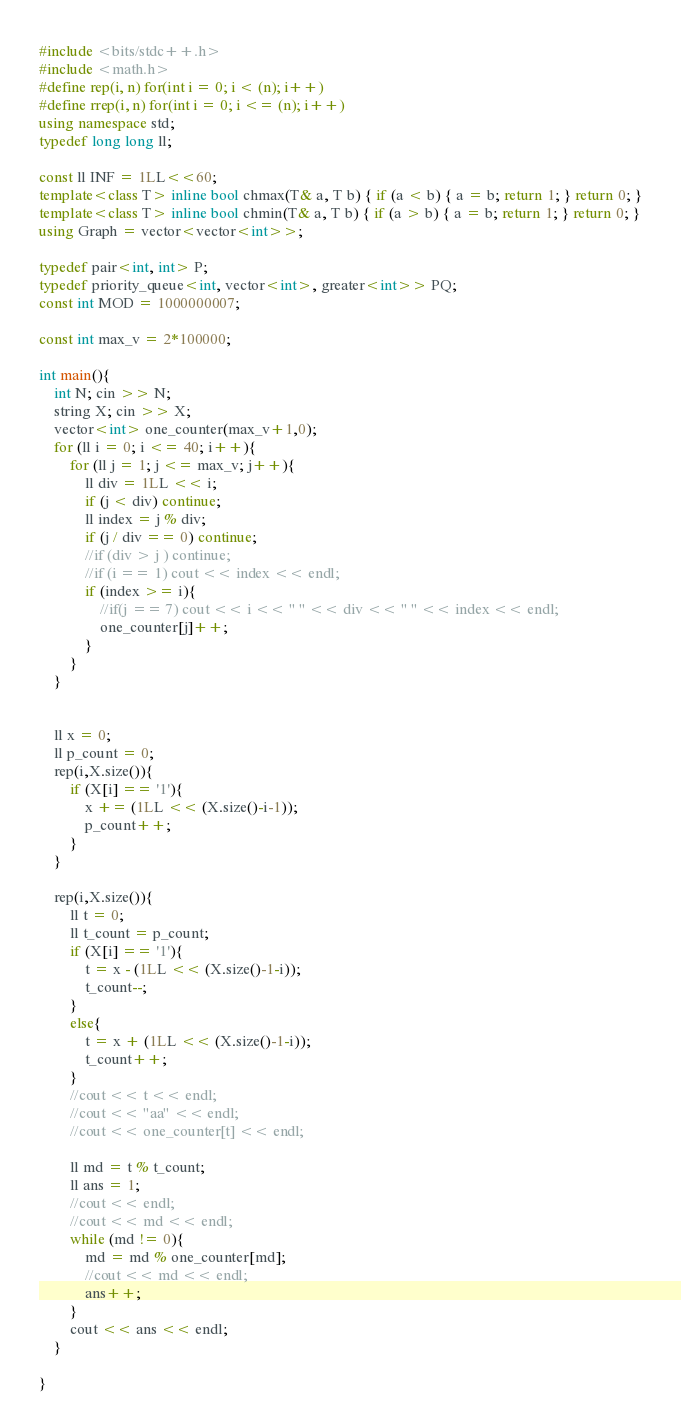Convert code to text. <code><loc_0><loc_0><loc_500><loc_500><_C++_>#include <bits/stdc++.h>
#include <math.h>
#define rep(i, n) for(int i = 0; i < (n); i++)
#define rrep(i, n) for(int i = 0; i <= (n); i++)
using namespace std;
typedef long long ll;
 
const ll INF = 1LL<<60;
template<class T> inline bool chmax(T& a, T b) { if (a < b) { a = b; return 1; } return 0; }
template<class T> inline bool chmin(T& a, T b) { if (a > b) { a = b; return 1; } return 0; }
using Graph = vector<vector<int>>;

typedef pair<int, int> P;
typedef priority_queue<int, vector<int>, greater<int>> PQ;
const int MOD = 1000000007;

const int max_v = 2*100000;

int main(){
    int N; cin >> N;
    string X; cin >> X;
    vector<int> one_counter(max_v+1,0);
    for (ll i = 0; i <= 40; i++){
        for (ll j = 1; j <= max_v; j++){
            ll div = 1LL << i;
            if (j < div) continue;
            ll index = j % div;
            if (j / div == 0) continue;
            //if (div > j ) continue;
            //if (i == 1) cout << index << endl;
            if (index >= i){
                //if(j == 7) cout << i << " " << div << " " << index << endl;
                one_counter[j]++;
            }
        }
    }


    ll x = 0;
    ll p_count = 0;
    rep(i,X.size()){
        if (X[i] == '1'){
            x += (1LL << (X.size()-i-1));
            p_count++;
        }
    }

    rep(i,X.size()){
        ll t = 0;
        ll t_count = p_count;
        if (X[i] == '1'){
            t = x - (1LL << (X.size()-1-i));
            t_count--; 
        }
        else{
            t = x + (1LL << (X.size()-1-i));
            t_count++;
        }
        //cout << t << endl;
        //cout << "aa" << endl;
        //cout << one_counter[t] << endl;
        
        ll md = t % t_count;
        ll ans = 1;
        //cout << endl;
        //cout << md << endl;
        while (md != 0){
            md = md % one_counter[md];
            //cout << md << endl;
            ans++;
        }
        cout << ans << endl;
    }

}
</code> 